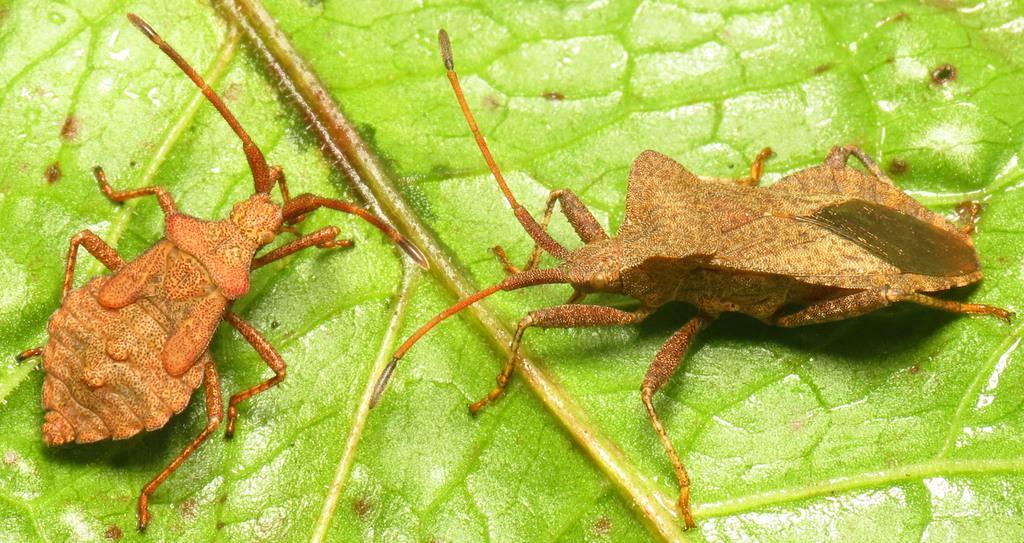In one or two sentences, can you explain what this image depicts? In this image, I can see two insects on the green leaf. 